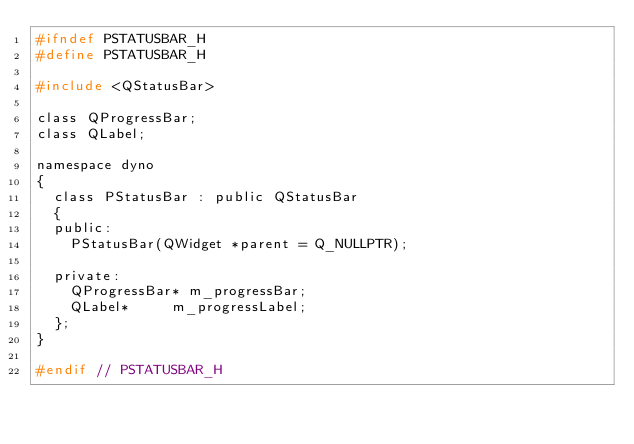Convert code to text. <code><loc_0><loc_0><loc_500><loc_500><_C_>#ifndef PSTATUSBAR_H
#define PSTATUSBAR_H

#include <QStatusBar>

class QProgressBar;
class QLabel;

namespace dyno
{
	class PStatusBar : public QStatusBar
	{
	public:
		PStatusBar(QWidget *parent = Q_NULLPTR);

	private:
		QProgressBar*	m_progressBar;
		QLabel*			m_progressLabel;
	};
}

#endif // PSTATUSBAR_H
</code> 